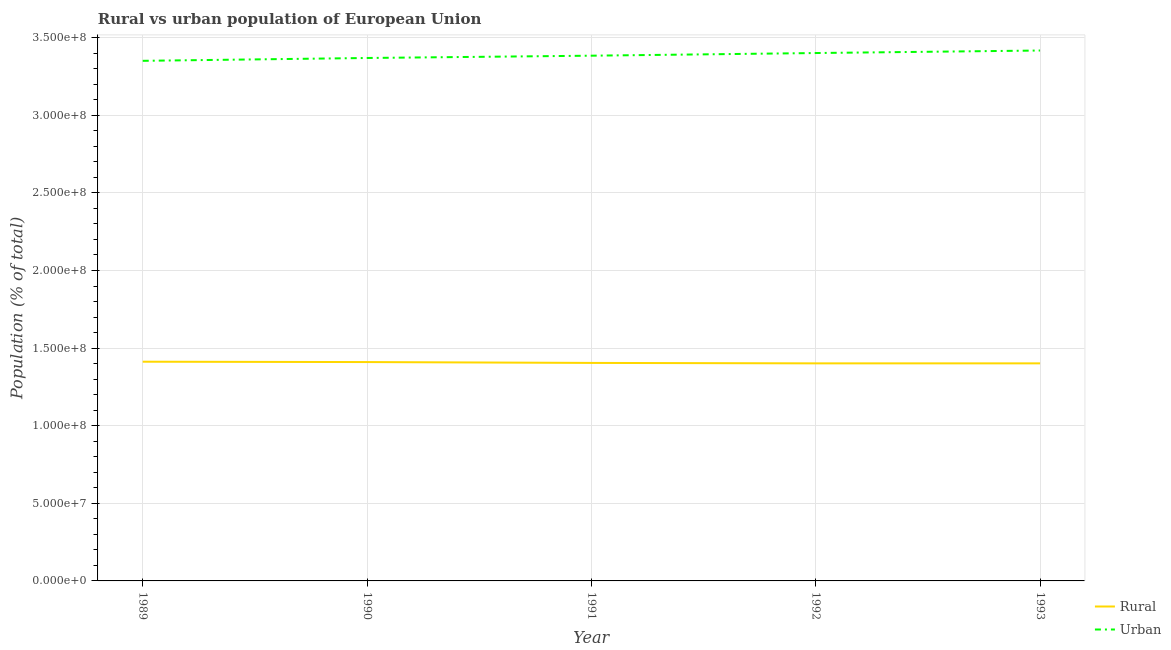How many different coloured lines are there?
Provide a succinct answer. 2. Does the line corresponding to rural population density intersect with the line corresponding to urban population density?
Provide a short and direct response. No. Is the number of lines equal to the number of legend labels?
Offer a terse response. Yes. What is the rural population density in 1992?
Your response must be concise. 1.40e+08. Across all years, what is the maximum rural population density?
Make the answer very short. 1.41e+08. Across all years, what is the minimum urban population density?
Your response must be concise. 3.35e+08. In which year was the urban population density maximum?
Your answer should be very brief. 1993. What is the total rural population density in the graph?
Your answer should be very brief. 7.03e+08. What is the difference between the rural population density in 1991 and that in 1993?
Keep it short and to the point. 2.85e+05. What is the difference between the urban population density in 1989 and the rural population density in 1990?
Your answer should be very brief. 1.94e+08. What is the average urban population density per year?
Provide a short and direct response. 3.38e+08. In the year 1991, what is the difference between the rural population density and urban population density?
Your answer should be very brief. -1.98e+08. What is the ratio of the rural population density in 1989 to that in 1990?
Your answer should be compact. 1. Is the difference between the urban population density in 1989 and 1992 greater than the difference between the rural population density in 1989 and 1992?
Ensure brevity in your answer.  No. What is the difference between the highest and the second highest urban population density?
Your response must be concise. 1.62e+06. What is the difference between the highest and the lowest rural population density?
Provide a succinct answer. 1.07e+06. In how many years, is the urban population density greater than the average urban population density taken over all years?
Give a very brief answer. 2. Is the sum of the urban population density in 1989 and 1993 greater than the maximum rural population density across all years?
Ensure brevity in your answer.  Yes. Is the urban population density strictly greater than the rural population density over the years?
Provide a succinct answer. Yes. Is the rural population density strictly less than the urban population density over the years?
Offer a very short reply. Yes. How many lines are there?
Offer a terse response. 2. What is the difference between two consecutive major ticks on the Y-axis?
Your answer should be compact. 5.00e+07. Does the graph contain any zero values?
Ensure brevity in your answer.  No. Where does the legend appear in the graph?
Offer a terse response. Bottom right. What is the title of the graph?
Make the answer very short. Rural vs urban population of European Union. Does "Male labourers" appear as one of the legend labels in the graph?
Offer a very short reply. No. What is the label or title of the Y-axis?
Offer a terse response. Population (% of total). What is the Population (% of total) of Rural in 1989?
Your answer should be very brief. 1.41e+08. What is the Population (% of total) of Urban in 1989?
Provide a succinct answer. 3.35e+08. What is the Population (% of total) in Rural in 1990?
Your response must be concise. 1.41e+08. What is the Population (% of total) in Urban in 1990?
Offer a terse response. 3.37e+08. What is the Population (% of total) of Rural in 1991?
Provide a succinct answer. 1.40e+08. What is the Population (% of total) in Urban in 1991?
Ensure brevity in your answer.  3.38e+08. What is the Population (% of total) in Rural in 1992?
Keep it short and to the point. 1.40e+08. What is the Population (% of total) of Urban in 1992?
Your answer should be very brief. 3.40e+08. What is the Population (% of total) of Rural in 1993?
Offer a terse response. 1.40e+08. What is the Population (% of total) in Urban in 1993?
Offer a very short reply. 3.42e+08. Across all years, what is the maximum Population (% of total) in Rural?
Offer a very short reply. 1.41e+08. Across all years, what is the maximum Population (% of total) in Urban?
Your answer should be very brief. 3.42e+08. Across all years, what is the minimum Population (% of total) in Rural?
Your answer should be compact. 1.40e+08. Across all years, what is the minimum Population (% of total) of Urban?
Provide a short and direct response. 3.35e+08. What is the total Population (% of total) in Rural in the graph?
Make the answer very short. 7.03e+08. What is the total Population (% of total) of Urban in the graph?
Your response must be concise. 1.69e+09. What is the difference between the Population (% of total) in Rural in 1989 and that in 1990?
Provide a short and direct response. 2.37e+05. What is the difference between the Population (% of total) in Urban in 1989 and that in 1990?
Your answer should be compact. -1.83e+06. What is the difference between the Population (% of total) in Rural in 1989 and that in 1991?
Your answer should be very brief. 7.87e+05. What is the difference between the Population (% of total) in Urban in 1989 and that in 1991?
Offer a terse response. -3.31e+06. What is the difference between the Population (% of total) of Rural in 1989 and that in 1992?
Your answer should be compact. 1.06e+06. What is the difference between the Population (% of total) of Urban in 1989 and that in 1992?
Offer a terse response. -5.02e+06. What is the difference between the Population (% of total) of Rural in 1989 and that in 1993?
Provide a succinct answer. 1.07e+06. What is the difference between the Population (% of total) of Urban in 1989 and that in 1993?
Your answer should be very brief. -6.64e+06. What is the difference between the Population (% of total) in Rural in 1990 and that in 1991?
Offer a very short reply. 5.50e+05. What is the difference between the Population (% of total) in Urban in 1990 and that in 1991?
Give a very brief answer. -1.48e+06. What is the difference between the Population (% of total) of Rural in 1990 and that in 1992?
Make the answer very short. 8.27e+05. What is the difference between the Population (% of total) in Urban in 1990 and that in 1992?
Your response must be concise. -3.19e+06. What is the difference between the Population (% of total) of Rural in 1990 and that in 1993?
Keep it short and to the point. 8.35e+05. What is the difference between the Population (% of total) of Urban in 1990 and that in 1993?
Offer a terse response. -4.81e+06. What is the difference between the Population (% of total) in Rural in 1991 and that in 1992?
Keep it short and to the point. 2.77e+05. What is the difference between the Population (% of total) of Urban in 1991 and that in 1992?
Keep it short and to the point. -1.71e+06. What is the difference between the Population (% of total) in Rural in 1991 and that in 1993?
Make the answer very short. 2.85e+05. What is the difference between the Population (% of total) of Urban in 1991 and that in 1993?
Offer a terse response. -3.33e+06. What is the difference between the Population (% of total) in Rural in 1992 and that in 1993?
Your response must be concise. 8270. What is the difference between the Population (% of total) of Urban in 1992 and that in 1993?
Ensure brevity in your answer.  -1.62e+06. What is the difference between the Population (% of total) of Rural in 1989 and the Population (% of total) of Urban in 1990?
Give a very brief answer. -1.96e+08. What is the difference between the Population (% of total) of Rural in 1989 and the Population (% of total) of Urban in 1991?
Give a very brief answer. -1.97e+08. What is the difference between the Population (% of total) in Rural in 1989 and the Population (% of total) in Urban in 1992?
Ensure brevity in your answer.  -1.99e+08. What is the difference between the Population (% of total) of Rural in 1989 and the Population (% of total) of Urban in 1993?
Your answer should be compact. -2.01e+08. What is the difference between the Population (% of total) of Rural in 1990 and the Population (% of total) of Urban in 1991?
Make the answer very short. -1.97e+08. What is the difference between the Population (% of total) in Rural in 1990 and the Population (% of total) in Urban in 1992?
Provide a short and direct response. -1.99e+08. What is the difference between the Population (% of total) of Rural in 1990 and the Population (% of total) of Urban in 1993?
Your answer should be very brief. -2.01e+08. What is the difference between the Population (% of total) of Rural in 1991 and the Population (% of total) of Urban in 1992?
Make the answer very short. -2.00e+08. What is the difference between the Population (% of total) of Rural in 1991 and the Population (% of total) of Urban in 1993?
Offer a very short reply. -2.01e+08. What is the difference between the Population (% of total) of Rural in 1992 and the Population (% of total) of Urban in 1993?
Your response must be concise. -2.02e+08. What is the average Population (% of total) in Rural per year?
Ensure brevity in your answer.  1.41e+08. What is the average Population (% of total) of Urban per year?
Your answer should be very brief. 3.38e+08. In the year 1989, what is the difference between the Population (% of total) in Rural and Population (% of total) in Urban?
Ensure brevity in your answer.  -1.94e+08. In the year 1990, what is the difference between the Population (% of total) of Rural and Population (% of total) of Urban?
Offer a very short reply. -1.96e+08. In the year 1991, what is the difference between the Population (% of total) of Rural and Population (% of total) of Urban?
Make the answer very short. -1.98e+08. In the year 1992, what is the difference between the Population (% of total) in Rural and Population (% of total) in Urban?
Your answer should be very brief. -2.00e+08. In the year 1993, what is the difference between the Population (% of total) of Rural and Population (% of total) of Urban?
Offer a very short reply. -2.02e+08. What is the ratio of the Population (% of total) of Rural in 1989 to that in 1991?
Make the answer very short. 1.01. What is the ratio of the Population (% of total) in Urban in 1989 to that in 1991?
Keep it short and to the point. 0.99. What is the ratio of the Population (% of total) of Rural in 1989 to that in 1992?
Your answer should be compact. 1.01. What is the ratio of the Population (% of total) in Urban in 1989 to that in 1992?
Offer a terse response. 0.99. What is the ratio of the Population (% of total) of Rural in 1989 to that in 1993?
Keep it short and to the point. 1.01. What is the ratio of the Population (% of total) in Urban in 1989 to that in 1993?
Keep it short and to the point. 0.98. What is the ratio of the Population (% of total) of Urban in 1990 to that in 1991?
Offer a very short reply. 1. What is the ratio of the Population (% of total) in Rural in 1990 to that in 1992?
Provide a succinct answer. 1.01. What is the ratio of the Population (% of total) in Urban in 1990 to that in 1992?
Ensure brevity in your answer.  0.99. What is the ratio of the Population (% of total) in Urban in 1990 to that in 1993?
Provide a short and direct response. 0.99. What is the ratio of the Population (% of total) of Rural in 1991 to that in 1992?
Your answer should be very brief. 1. What is the ratio of the Population (% of total) in Rural in 1991 to that in 1993?
Provide a short and direct response. 1. What is the ratio of the Population (% of total) in Urban in 1991 to that in 1993?
Your response must be concise. 0.99. What is the ratio of the Population (% of total) of Urban in 1992 to that in 1993?
Your answer should be very brief. 1. What is the difference between the highest and the second highest Population (% of total) of Rural?
Your answer should be very brief. 2.37e+05. What is the difference between the highest and the second highest Population (% of total) of Urban?
Your response must be concise. 1.62e+06. What is the difference between the highest and the lowest Population (% of total) in Rural?
Ensure brevity in your answer.  1.07e+06. What is the difference between the highest and the lowest Population (% of total) in Urban?
Make the answer very short. 6.64e+06. 